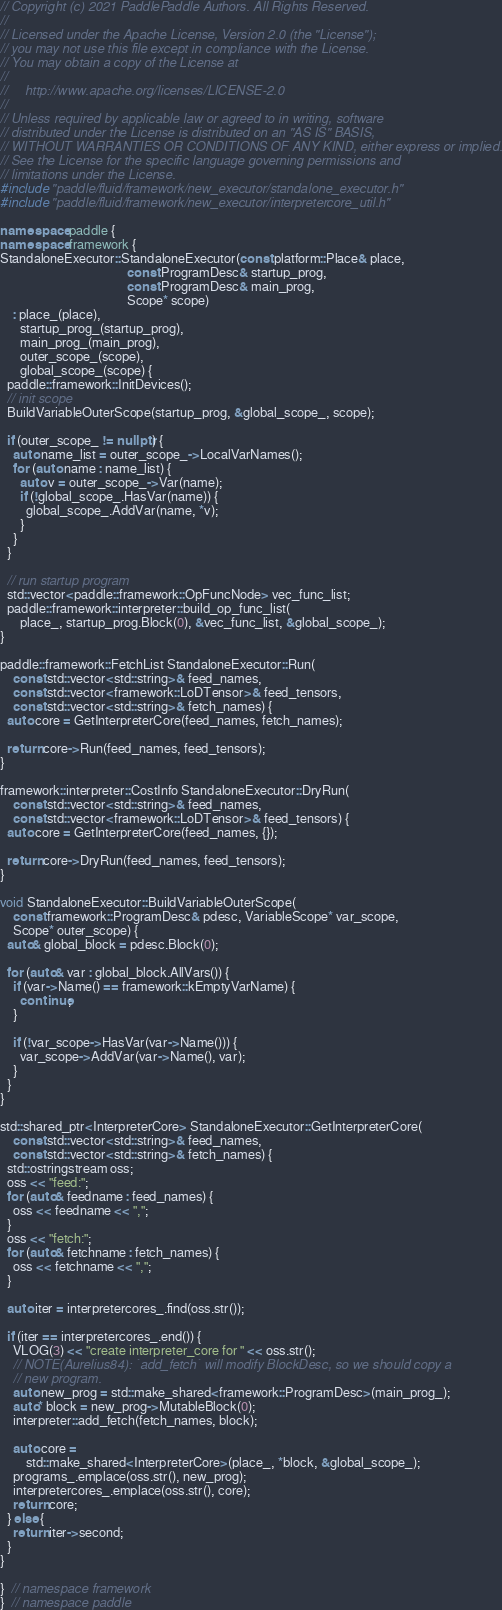Convert code to text. <code><loc_0><loc_0><loc_500><loc_500><_C++_>// Copyright (c) 2021 PaddlePaddle Authors. All Rights Reserved.
//
// Licensed under the Apache License, Version 2.0 (the "License");
// you may not use this file except in compliance with the License.
// You may obtain a copy of the License at
//
//     http://www.apache.org/licenses/LICENSE-2.0
//
// Unless required by applicable law or agreed to in writing, software
// distributed under the License is distributed on an "AS IS" BASIS,
// WITHOUT WARRANTIES OR CONDITIONS OF ANY KIND, either express or implied.
// See the License for the specific language governing permissions and
// limitations under the License.
#include "paddle/fluid/framework/new_executor/standalone_executor.h"
#include "paddle/fluid/framework/new_executor/interpretercore_util.h"

namespace paddle {
namespace framework {
StandaloneExecutor::StandaloneExecutor(const platform::Place& place,
                                       const ProgramDesc& startup_prog,
                                       const ProgramDesc& main_prog,
                                       Scope* scope)
    : place_(place),
      startup_prog_(startup_prog),
      main_prog_(main_prog),
      outer_scope_(scope),
      global_scope_(scope) {
  paddle::framework::InitDevices();
  // init scope
  BuildVariableOuterScope(startup_prog, &global_scope_, scope);

  if (outer_scope_ != nullptr) {
    auto name_list = outer_scope_->LocalVarNames();
    for (auto name : name_list) {
      auto v = outer_scope_->Var(name);
      if (!global_scope_.HasVar(name)) {
        global_scope_.AddVar(name, *v);
      }
    }
  }

  // run startup program
  std::vector<paddle::framework::OpFuncNode> vec_func_list;
  paddle::framework::interpreter::build_op_func_list(
      place_, startup_prog.Block(0), &vec_func_list, &global_scope_);
}

paddle::framework::FetchList StandaloneExecutor::Run(
    const std::vector<std::string>& feed_names,
    const std::vector<framework::LoDTensor>& feed_tensors,
    const std::vector<std::string>& fetch_names) {
  auto core = GetInterpreterCore(feed_names, fetch_names);

  return core->Run(feed_names, feed_tensors);
}

framework::interpreter::CostInfo StandaloneExecutor::DryRun(
    const std::vector<std::string>& feed_names,
    const std::vector<framework::LoDTensor>& feed_tensors) {
  auto core = GetInterpreterCore(feed_names, {});

  return core->DryRun(feed_names, feed_tensors);
}

void StandaloneExecutor::BuildVariableOuterScope(
    const framework::ProgramDesc& pdesc, VariableScope* var_scope,
    Scope* outer_scope) {
  auto& global_block = pdesc.Block(0);

  for (auto& var : global_block.AllVars()) {
    if (var->Name() == framework::kEmptyVarName) {
      continue;
    }

    if (!var_scope->HasVar(var->Name())) {
      var_scope->AddVar(var->Name(), var);
    }
  }
}

std::shared_ptr<InterpreterCore> StandaloneExecutor::GetInterpreterCore(
    const std::vector<std::string>& feed_names,
    const std::vector<std::string>& fetch_names) {
  std::ostringstream oss;
  oss << "feed:";
  for (auto& feedname : feed_names) {
    oss << feedname << ",";
  }
  oss << "fetch:";
  for (auto& fetchname : fetch_names) {
    oss << fetchname << ",";
  }

  auto iter = interpretercores_.find(oss.str());

  if (iter == interpretercores_.end()) {
    VLOG(3) << "create interpreter_core for " << oss.str();
    // NOTE(Aurelius84): `add_fetch` will modify BlockDesc, so we should copy a
    // new program.
    auto new_prog = std::make_shared<framework::ProgramDesc>(main_prog_);
    auto* block = new_prog->MutableBlock(0);
    interpreter::add_fetch(fetch_names, block);

    auto core =
        std::make_shared<InterpreterCore>(place_, *block, &global_scope_);
    programs_.emplace(oss.str(), new_prog);
    interpretercores_.emplace(oss.str(), core);
    return core;
  } else {
    return iter->second;
  }
}

}  // namespace framework
}  // namespace paddle
</code> 